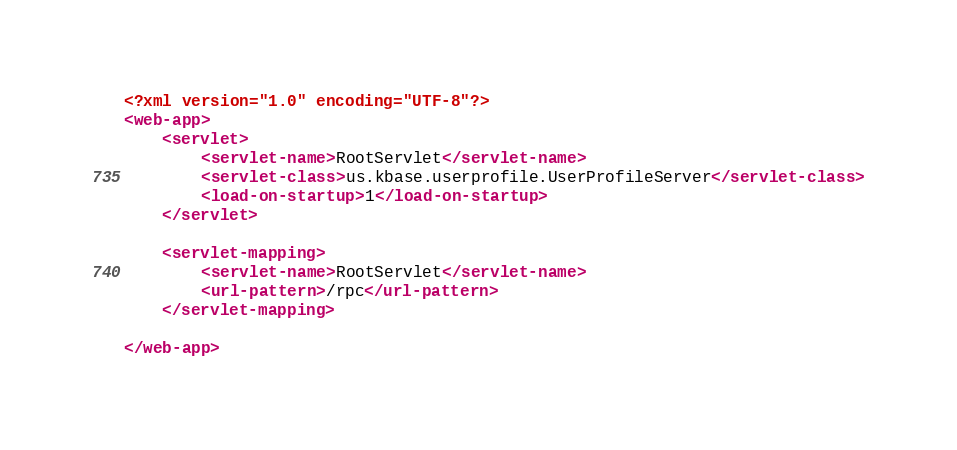Convert code to text. <code><loc_0><loc_0><loc_500><loc_500><_XML_><?xml version="1.0" encoding="UTF-8"?>
<web-app>
    <servlet>
        <servlet-name>RootServlet</servlet-name>
        <servlet-class>us.kbase.userprofile.UserProfileServer</servlet-class>
        <load-on-startup>1</load-on-startup>
    </servlet>

    <servlet-mapping>
        <servlet-name>RootServlet</servlet-name>
        <url-pattern>/rpc</url-pattern>
    </servlet-mapping>

</web-app>
</code> 